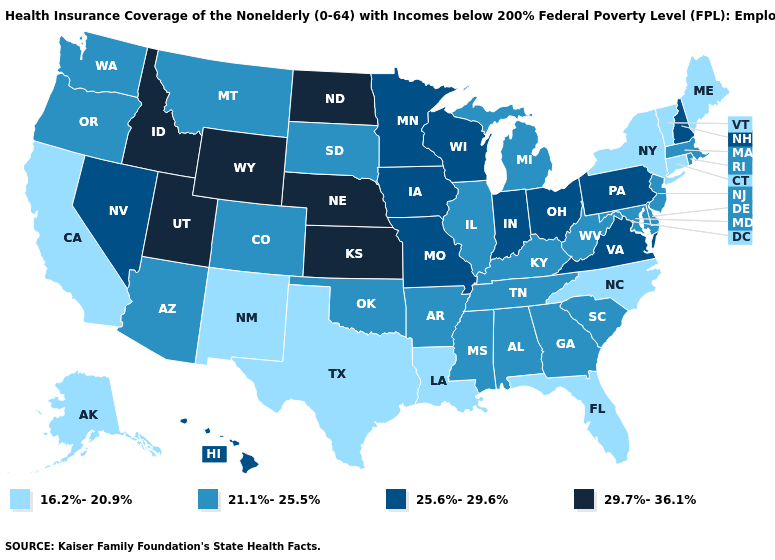Name the states that have a value in the range 21.1%-25.5%?
Be succinct. Alabama, Arizona, Arkansas, Colorado, Delaware, Georgia, Illinois, Kentucky, Maryland, Massachusetts, Michigan, Mississippi, Montana, New Jersey, Oklahoma, Oregon, Rhode Island, South Carolina, South Dakota, Tennessee, Washington, West Virginia. What is the value of Ohio?
Give a very brief answer. 25.6%-29.6%. Does Georgia have the lowest value in the South?
Write a very short answer. No. Does Wyoming have the highest value in the USA?
Be succinct. Yes. What is the lowest value in the West?
Quick response, please. 16.2%-20.9%. What is the value of Colorado?
Be succinct. 21.1%-25.5%. What is the value of West Virginia?
Write a very short answer. 21.1%-25.5%. Name the states that have a value in the range 29.7%-36.1%?
Short answer required. Idaho, Kansas, Nebraska, North Dakota, Utah, Wyoming. Does the map have missing data?
Give a very brief answer. No. Name the states that have a value in the range 16.2%-20.9%?
Keep it brief. Alaska, California, Connecticut, Florida, Louisiana, Maine, New Mexico, New York, North Carolina, Texas, Vermont. Is the legend a continuous bar?
Short answer required. No. Does Maryland have the highest value in the USA?
Give a very brief answer. No. What is the value of California?
Short answer required. 16.2%-20.9%. Name the states that have a value in the range 21.1%-25.5%?
Concise answer only. Alabama, Arizona, Arkansas, Colorado, Delaware, Georgia, Illinois, Kentucky, Maryland, Massachusetts, Michigan, Mississippi, Montana, New Jersey, Oklahoma, Oregon, Rhode Island, South Carolina, South Dakota, Tennessee, Washington, West Virginia. Among the states that border Montana , which have the lowest value?
Write a very short answer. South Dakota. 